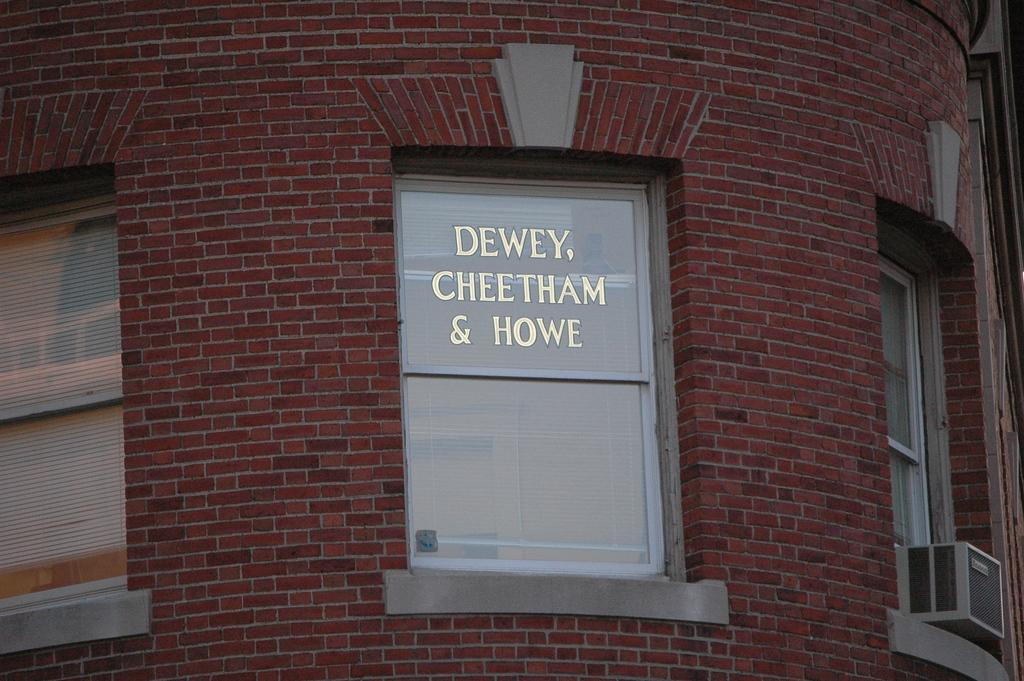What type of structure is visible on the wall in the image? There are windows on the wall of the building. What material is the wall made of? The wall is made up of red bricks. What can be seen attached to the windows in the image? There is an AC outdoor unit box kept on the window. What type of stew is being prepared in the image? There is no stew present in the image; it features a building with windows and a red brick wall. What liquid is visible in the image? There is no liquid visible in the image. How much sugar is present in the image? There is no sugar present in the image. 